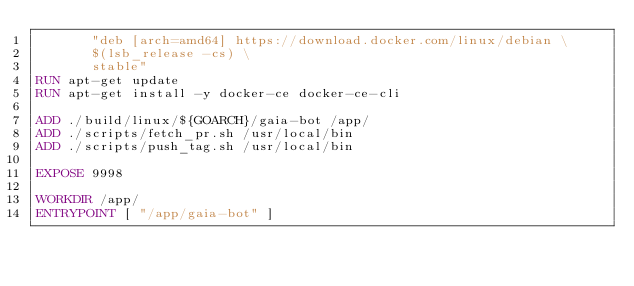Convert code to text. <code><loc_0><loc_0><loc_500><loc_500><_Dockerfile_>       "deb [arch=amd64] https://download.docker.com/linux/debian \
       $(lsb_release -cs) \
       stable"
RUN apt-get update
RUN apt-get install -y docker-ce docker-ce-cli

ADD ./build/linux/${GOARCH}/gaia-bot /app/
ADD ./scripts/fetch_pr.sh /usr/local/bin
ADD ./scripts/push_tag.sh /usr/local/bin

EXPOSE 9998

WORKDIR /app/
ENTRYPOINT [ "/app/gaia-bot" ]
</code> 